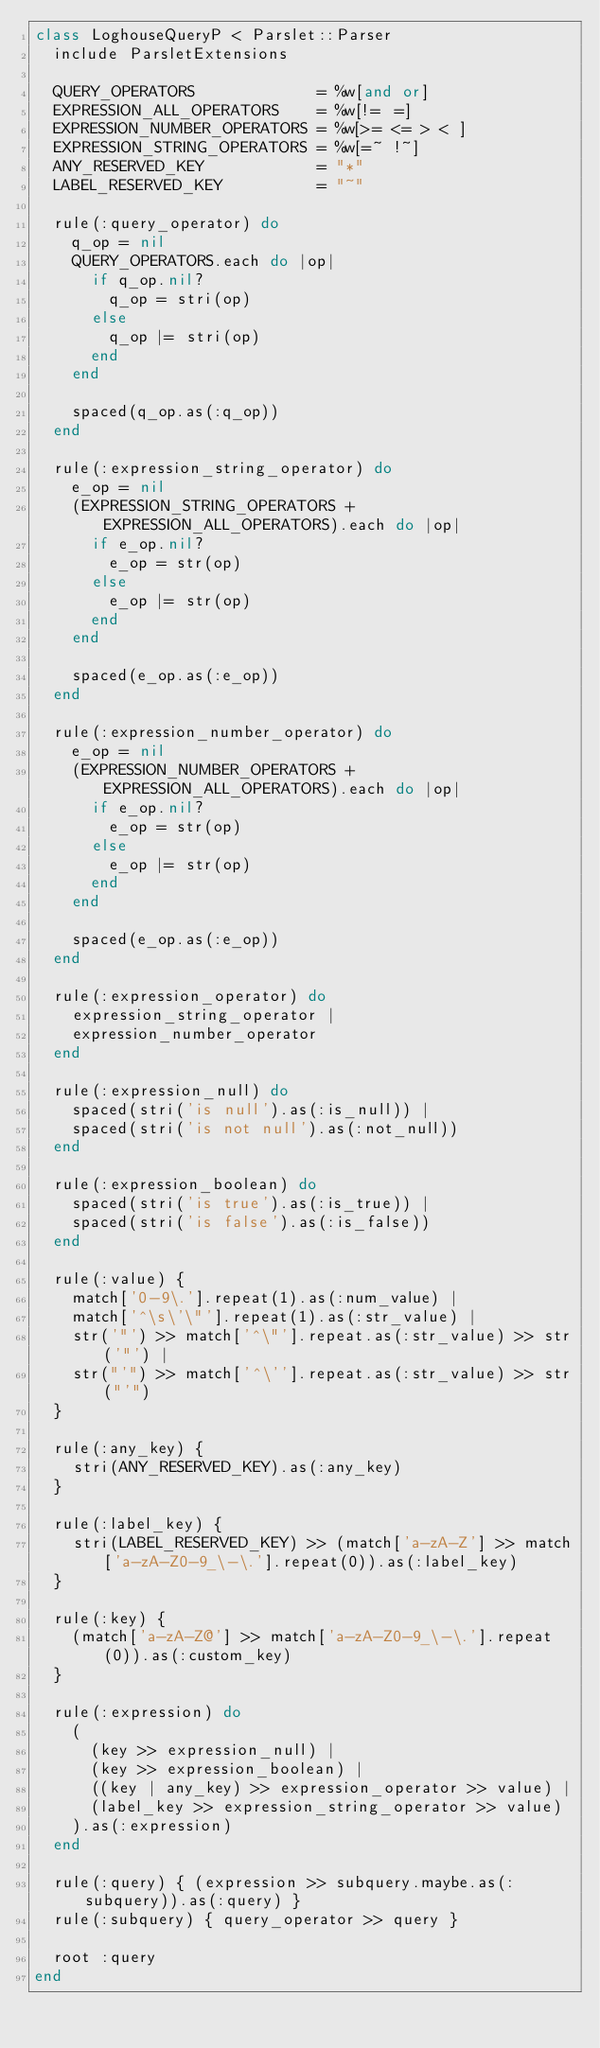<code> <loc_0><loc_0><loc_500><loc_500><_Ruby_>class LoghouseQueryP < Parslet::Parser
  include ParsletExtensions

  QUERY_OPERATORS             = %w[and or]
  EXPRESSION_ALL_OPERATORS    = %w[!= =]
  EXPRESSION_NUMBER_OPERATORS = %w[>= <= > < ]
  EXPRESSION_STRING_OPERATORS = %w[=~ !~]
  ANY_RESERVED_KEY            = "*"
  LABEL_RESERVED_KEY          = "~"

  rule(:query_operator) do
    q_op = nil
    QUERY_OPERATORS.each do |op|
      if q_op.nil?
        q_op = stri(op)
      else
        q_op |= stri(op)
      end
    end

    spaced(q_op.as(:q_op))
  end

  rule(:expression_string_operator) do
    e_op = nil
    (EXPRESSION_STRING_OPERATORS + EXPRESSION_ALL_OPERATORS).each do |op|
      if e_op.nil?
        e_op = str(op)
      else
        e_op |= str(op)
      end
    end

    spaced(e_op.as(:e_op))
  end

  rule(:expression_number_operator) do
    e_op = nil
    (EXPRESSION_NUMBER_OPERATORS + EXPRESSION_ALL_OPERATORS).each do |op|
      if e_op.nil?
        e_op = str(op)
      else
        e_op |= str(op)
      end
    end

    spaced(e_op.as(:e_op))
  end

  rule(:expression_operator) do
    expression_string_operator |
    expression_number_operator
  end

  rule(:expression_null) do
    spaced(stri('is null').as(:is_null)) |
    spaced(stri('is not null').as(:not_null))
  end

  rule(:expression_boolean) do
    spaced(stri('is true').as(:is_true)) |
    spaced(stri('is false').as(:is_false))
  end

  rule(:value) {
    match['0-9\.'].repeat(1).as(:num_value) |
    match['^\s\'\"'].repeat(1).as(:str_value) |
    str('"') >> match['^\"'].repeat.as(:str_value) >> str('"') |
    str("'") >> match['^\''].repeat.as(:str_value) >> str("'")
  }

  rule(:any_key) {
    stri(ANY_RESERVED_KEY).as(:any_key)
  }

  rule(:label_key) {
    stri(LABEL_RESERVED_KEY) >> (match['a-zA-Z'] >> match['a-zA-Z0-9_\-\.'].repeat(0)).as(:label_key)
  }

  rule(:key) {
    (match['a-zA-Z@'] >> match['a-zA-Z0-9_\-\.'].repeat(0)).as(:custom_key)
  }

  rule(:expression) do
    (
      (key >> expression_null) |
      (key >> expression_boolean) |
      ((key | any_key) >> expression_operator >> value) |
      (label_key >> expression_string_operator >> value)
    ).as(:expression)
  end

  rule(:query) { (expression >> subquery.maybe.as(:subquery)).as(:query) }
  rule(:subquery) { query_operator >> query }

  root :query
end
</code> 